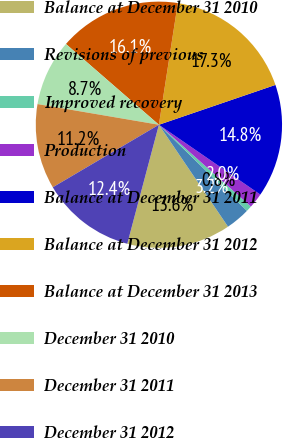<chart> <loc_0><loc_0><loc_500><loc_500><pie_chart><fcel>Balance at December 31 2010<fcel>Revisions of previous<fcel>Improved recovery<fcel>Production<fcel>Balance at December 31 2011<fcel>Balance at December 31 2012<fcel>Balance at December 31 2013<fcel>December 31 2010<fcel>December 31 2011<fcel>December 31 2012<nl><fcel>13.62%<fcel>3.2%<fcel>0.75%<fcel>1.97%<fcel>14.84%<fcel>17.3%<fcel>16.07%<fcel>8.7%<fcel>11.16%<fcel>12.39%<nl></chart> 